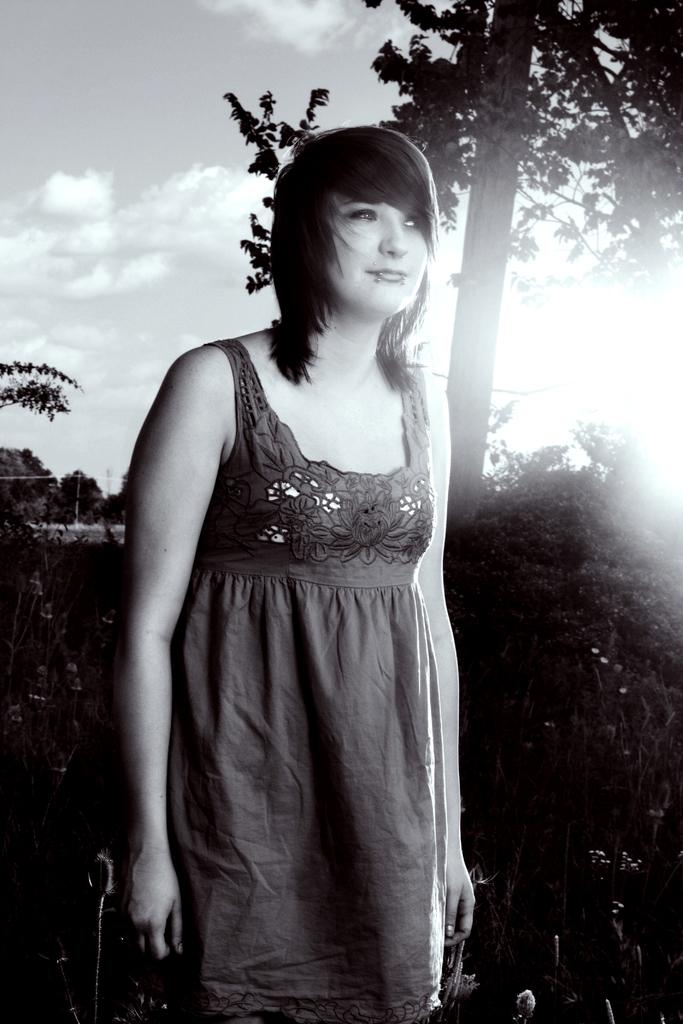Who is the main subject in the image? There is a woman in the image. What is the woman doing in the image? The woman is standing in front. What can be seen behind the woman in the image? There are plants and trees behind the woman. What is visible in the background of the image? The sky is visible in the background of the image. How does the woman increase the number of plants in the image? The image does not show the woman increasing the number of plants; it only shows her standing in front of existing plants and trees. 